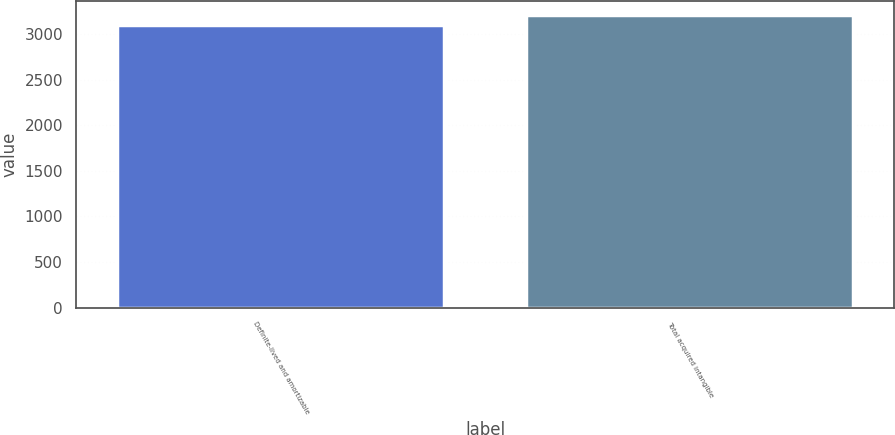<chart> <loc_0><loc_0><loc_500><loc_500><bar_chart><fcel>Definite-lived and amortizable<fcel>Total acquired intangible<nl><fcel>3106<fcel>3206<nl></chart> 